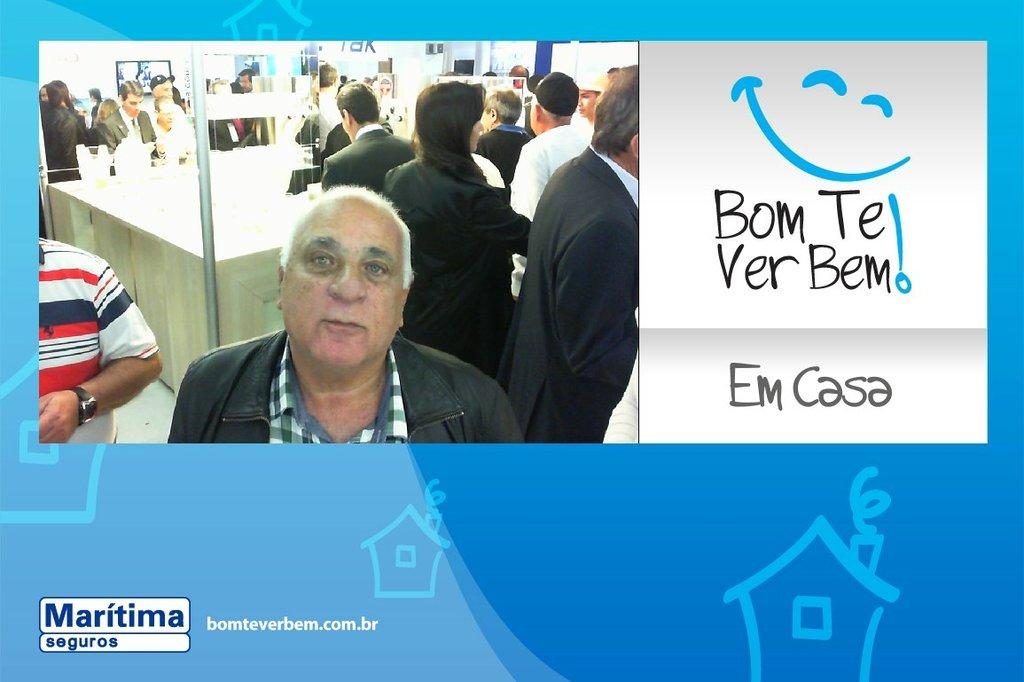<image>
Create a compact narrative representing the image presented. Man next to a white sign that says "Em Casa". 